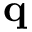Convert formula to latex. <formula><loc_0><loc_0><loc_500><loc_500>q</formula> 